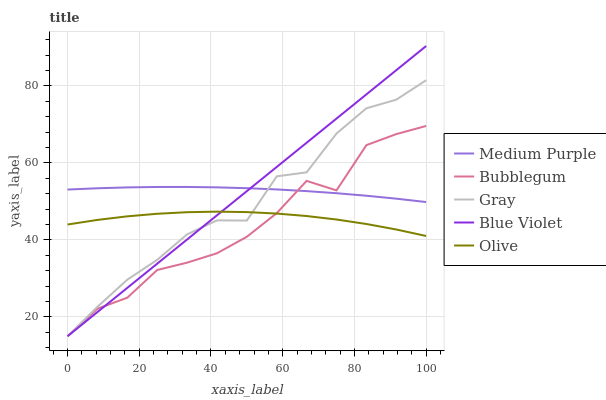Does Bubblegum have the minimum area under the curve?
Answer yes or no. Yes. Does Medium Purple have the maximum area under the curve?
Answer yes or no. Yes. Does Gray have the minimum area under the curve?
Answer yes or no. No. Does Gray have the maximum area under the curve?
Answer yes or no. No. Is Blue Violet the smoothest?
Answer yes or no. Yes. Is Bubblegum the roughest?
Answer yes or no. Yes. Is Gray the smoothest?
Answer yes or no. No. Is Gray the roughest?
Answer yes or no. No. Does Olive have the lowest value?
Answer yes or no. No. Does Blue Violet have the highest value?
Answer yes or no. Yes. Does Gray have the highest value?
Answer yes or no. No. Is Olive less than Medium Purple?
Answer yes or no. Yes. Is Medium Purple greater than Olive?
Answer yes or no. Yes. Does Blue Violet intersect Gray?
Answer yes or no. Yes. Is Blue Violet less than Gray?
Answer yes or no. No. Is Blue Violet greater than Gray?
Answer yes or no. No. Does Olive intersect Medium Purple?
Answer yes or no. No. 